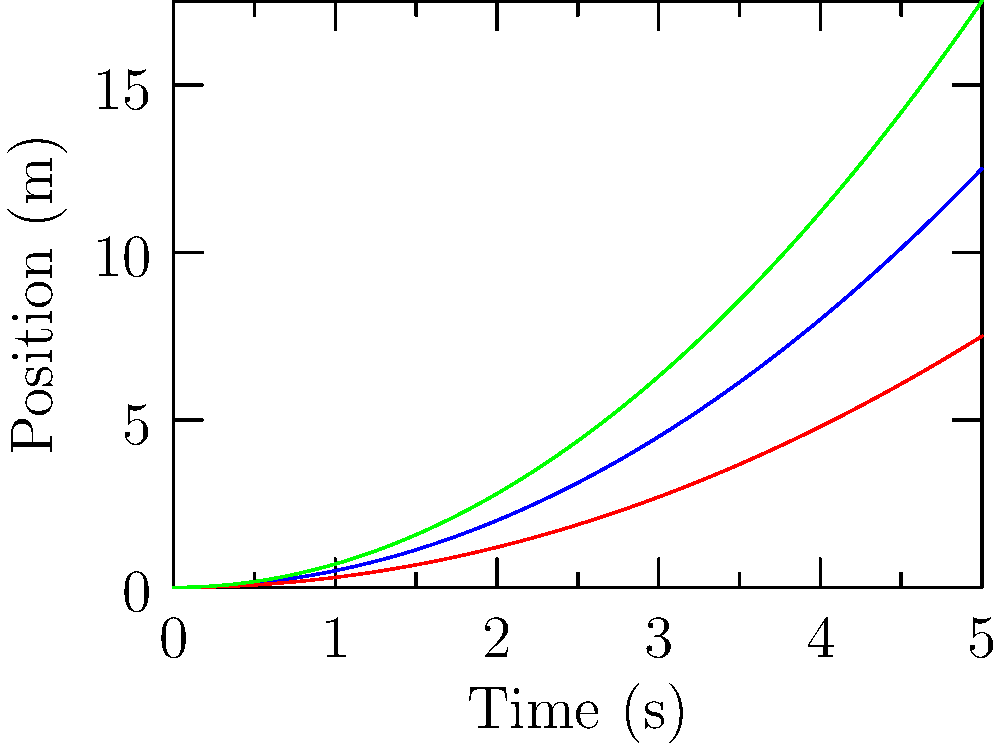Given the position-time graphs for three players with different body types, which player has the highest constant acceleration? To determine which player has the highest constant acceleration, we need to analyze the position-time graphs:

1. Recall that for constant acceleration, the position-time graph is a parabola of the form:
   $x(t) = \frac{1}{2}at^2 + v_0t + x_0$
   
   where $a$ is the acceleration, $v_0$ is the initial velocity, and $x_0$ is the initial position.

2. In this case, all players start from rest ($v_0 = 0$) and the same initial position ($x_0 = 0$).

3. The graphs show parabolas of the form $x(t) = kt^2$, where $k = \frac{1}{2}a$.

4. To find the acceleration, we need to identify which curve has the largest $k$ value:
   - Player A (blue): $x(t) = 0.5t^2$
   - Player B (red): $x(t) = 0.3t^2$
   - Player C (green): $x(t) = 0.7t^2$

5. Player C has the largest $k$ value (0.7).

6. The acceleration for Player C is:
   $a = 2k = 2(0.7) = 1.4$ m/s²

Therefore, Player C has the highest constant acceleration.
Answer: Player C 